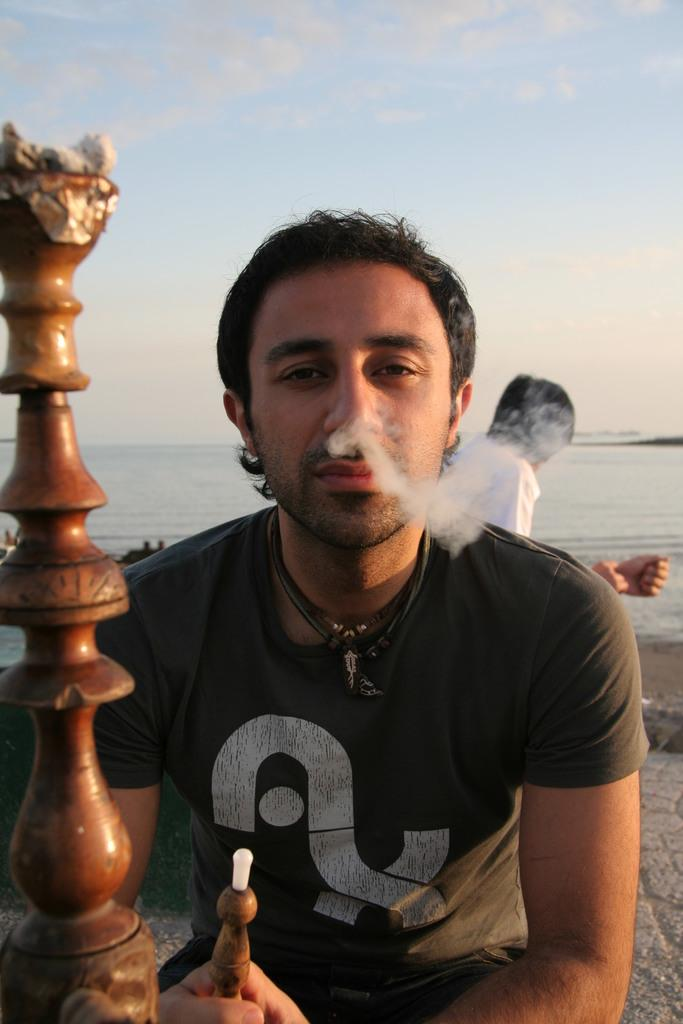What is the man in the image holding? The man in the image is holding a hookah. Can you describe the person behind the man? There is another person behind the man, but their appearance or actions are not specified in the facts. What can be seen in the background of the image? There is a water body and the sky visible in the background of the image. How much food is present on the table in the image? There is no table or food mentioned in the facts, so we cannot determine the amount of food present in the image. 